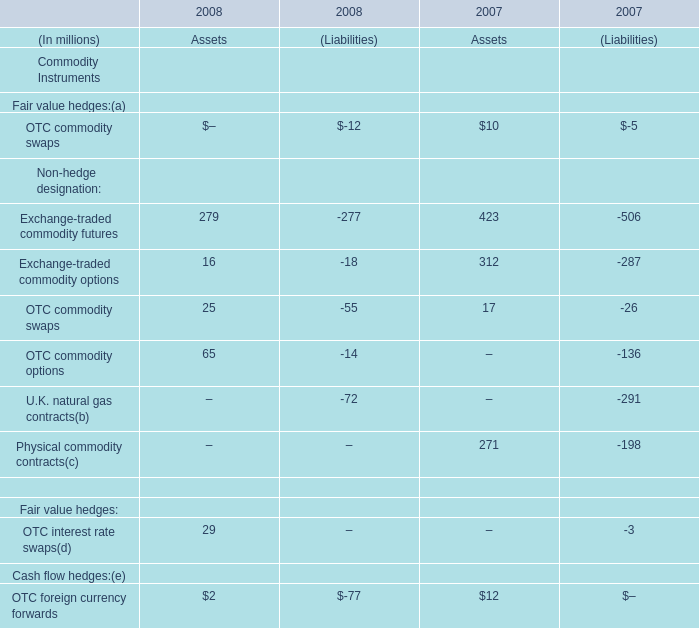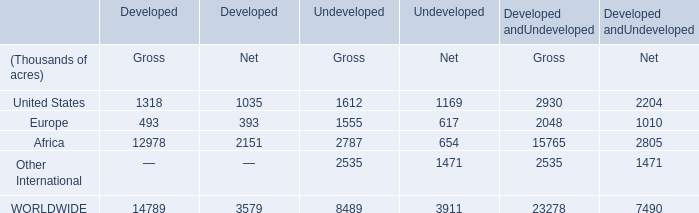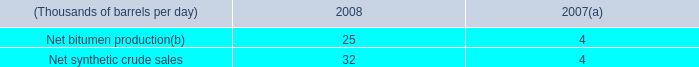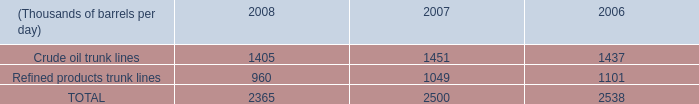what was total miles of private crude oil pipelines and private refined products pipelines? 
Computations: (176 + 850)
Answer: 1026.0. 